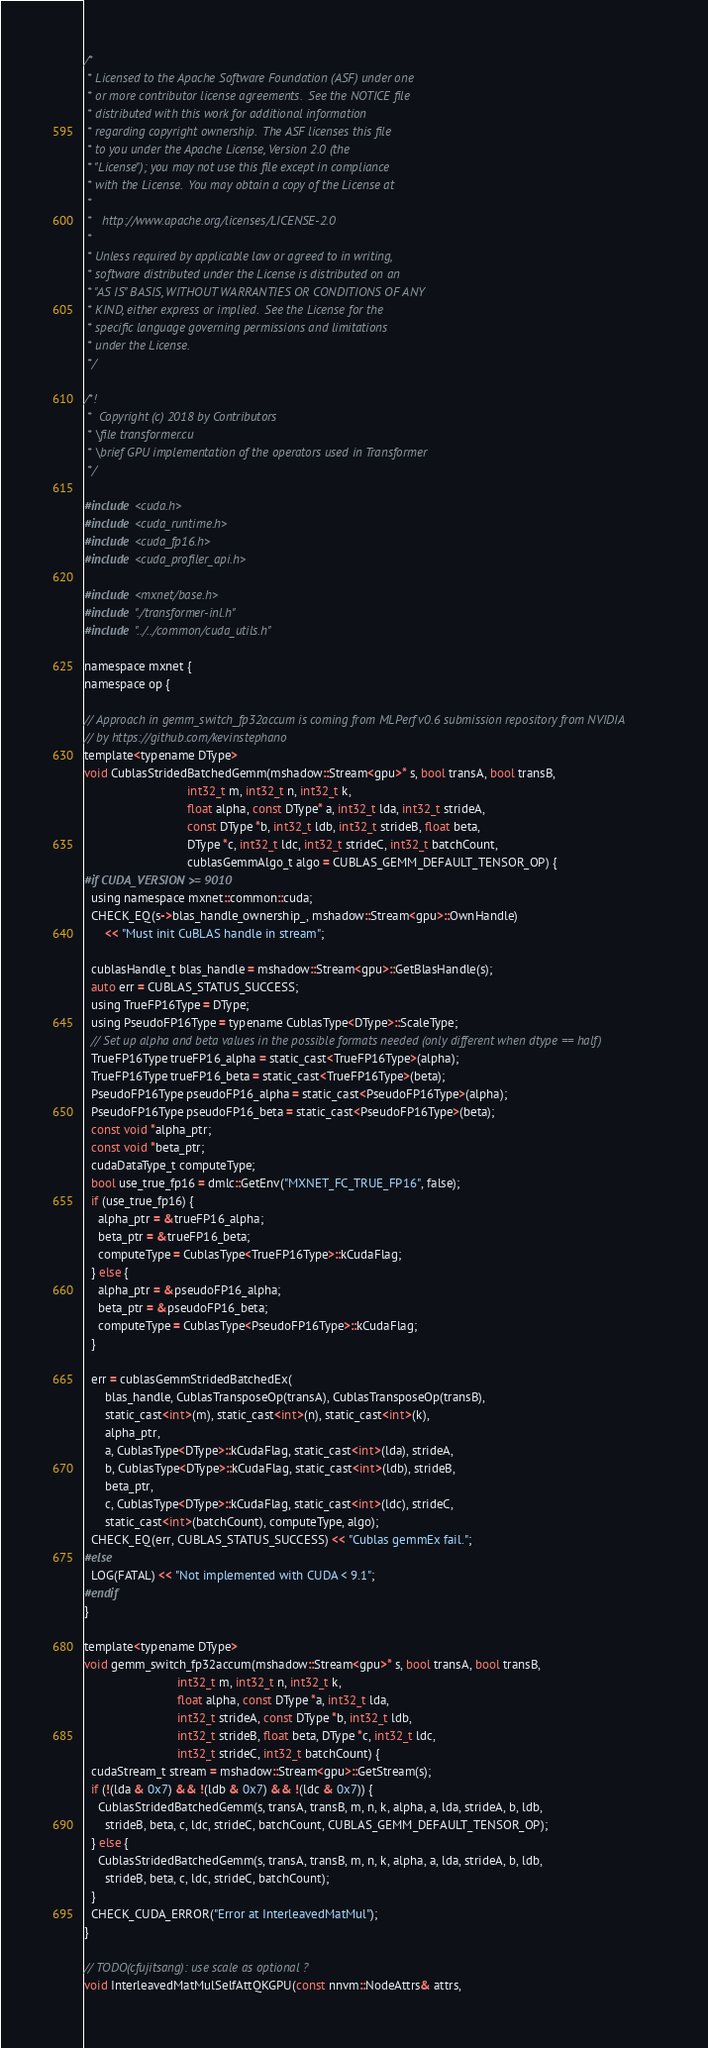Convert code to text. <code><loc_0><loc_0><loc_500><loc_500><_Cuda_>/*
 * Licensed to the Apache Software Foundation (ASF) under one
 * or more contributor license agreements.  See the NOTICE file
 * distributed with this work for additional information
 * regarding copyright ownership.  The ASF licenses this file
 * to you under the Apache License, Version 2.0 (the
 * "License"); you may not use this file except in compliance
 * with the License.  You may obtain a copy of the License at
 *
 *   http://www.apache.org/licenses/LICENSE-2.0
 *
 * Unless required by applicable law or agreed to in writing,
 * software distributed under the License is distributed on an
 * "AS IS" BASIS, WITHOUT WARRANTIES OR CONDITIONS OF ANY
 * KIND, either express or implied.  See the License for the
 * specific language governing permissions and limitations
 * under the License.
 */

/*!
 *  Copyright (c) 2018 by Contributors
 * \file transformer.cu
 * \brief GPU implementation of the operators used in Transformer
 */

#include <cuda.h>
#include <cuda_runtime.h>
#include <cuda_fp16.h>
#include <cuda_profiler_api.h>

#include <mxnet/base.h>
#include "./transformer-inl.h"
#include "../../common/cuda_utils.h"

namespace mxnet {
namespace op {

// Approach in gemm_switch_fp32accum is coming from MLPerf v0.6 submission repository from NVIDIA
// by https://github.com/kevinstephano
template<typename DType>
void CublasStridedBatchedGemm(mshadow::Stream<gpu>* s, bool transA, bool transB,
                              int32_t m, int32_t n, int32_t k,
                              float alpha, const DType* a, int32_t lda, int32_t strideA,
                              const DType *b, int32_t ldb, int32_t strideB, float beta,
                              DType *c, int32_t ldc, int32_t strideC, int32_t batchCount,
                              cublasGemmAlgo_t algo = CUBLAS_GEMM_DEFAULT_TENSOR_OP) {
#if CUDA_VERSION >= 9010
  using namespace mxnet::common::cuda;
  CHECK_EQ(s->blas_handle_ownership_, mshadow::Stream<gpu>::OwnHandle)
      << "Must init CuBLAS handle in stream";

  cublasHandle_t blas_handle = mshadow::Stream<gpu>::GetBlasHandle(s);
  auto err = CUBLAS_STATUS_SUCCESS;
  using TrueFP16Type = DType;
  using PseudoFP16Type = typename CublasType<DType>::ScaleType;
  // Set up alpha and beta values in the possible formats needed (only different when dtype == half)
  TrueFP16Type trueFP16_alpha = static_cast<TrueFP16Type>(alpha);
  TrueFP16Type trueFP16_beta = static_cast<TrueFP16Type>(beta);
  PseudoFP16Type pseudoFP16_alpha = static_cast<PseudoFP16Type>(alpha);
  PseudoFP16Type pseudoFP16_beta = static_cast<PseudoFP16Type>(beta);
  const void *alpha_ptr;
  const void *beta_ptr;
  cudaDataType_t computeType;
  bool use_true_fp16 = dmlc::GetEnv("MXNET_FC_TRUE_FP16", false);
  if (use_true_fp16) {
    alpha_ptr = &trueFP16_alpha;
    beta_ptr = &trueFP16_beta;
    computeType = CublasType<TrueFP16Type>::kCudaFlag;
  } else {
    alpha_ptr = &pseudoFP16_alpha;
    beta_ptr = &pseudoFP16_beta;
    computeType = CublasType<PseudoFP16Type>::kCudaFlag;
  }

  err = cublasGemmStridedBatchedEx(
      blas_handle, CublasTransposeOp(transA), CublasTransposeOp(transB),
      static_cast<int>(m), static_cast<int>(n), static_cast<int>(k),
      alpha_ptr,
      a, CublasType<DType>::kCudaFlag, static_cast<int>(lda), strideA,
      b, CublasType<DType>::kCudaFlag, static_cast<int>(ldb), strideB,
      beta_ptr,
      c, CublasType<DType>::kCudaFlag, static_cast<int>(ldc), strideC,
      static_cast<int>(batchCount), computeType, algo);
  CHECK_EQ(err, CUBLAS_STATUS_SUCCESS) << "Cublas gemmEx fail.";
#else
  LOG(FATAL) << "Not implemented with CUDA < 9.1";
#endif
}

template<typename DType>
void gemm_switch_fp32accum(mshadow::Stream<gpu>* s, bool transA, bool transB,
                           int32_t m, int32_t n, int32_t k,
                           float alpha, const DType *a, int32_t lda,
                           int32_t strideA, const DType *b, int32_t ldb,
                           int32_t strideB, float beta, DType *c, int32_t ldc,
                           int32_t strideC, int32_t batchCount) {
  cudaStream_t stream = mshadow::Stream<gpu>::GetStream(s);
  if (!(lda & 0x7) && !(ldb & 0x7) && !(ldc & 0x7)) {
    CublasStridedBatchedGemm(s, transA, transB, m, n, k, alpha, a, lda, strideA, b, ldb,
      strideB, beta, c, ldc, strideC, batchCount, CUBLAS_GEMM_DEFAULT_TENSOR_OP);
  } else {
    CublasStridedBatchedGemm(s, transA, transB, m, n, k, alpha, a, lda, strideA, b, ldb,
      strideB, beta, c, ldc, strideC, batchCount);
  }
  CHECK_CUDA_ERROR("Error at InterleavedMatMul");
}

// TODO(cfujitsang): use scale as optional ?
void InterleavedMatMulSelfAttQKGPU(const nnvm::NodeAttrs& attrs,</code> 